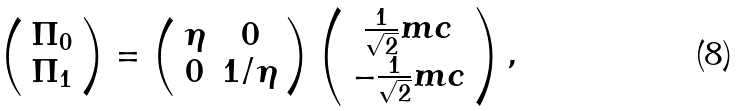Convert formula to latex. <formula><loc_0><loc_0><loc_500><loc_500>\left ( \begin{array} { c } \Pi _ { 0 } \\ \Pi _ { 1 } \end{array} \right ) = \left ( \begin{array} { c c } \eta & 0 \\ 0 & 1 / \eta \end{array} \right ) \left ( \begin{array} { c } \frac { 1 } { \sqrt { 2 } } m c \\ - \frac { 1 } { \sqrt { 2 } } m c \end{array} \right ) ,</formula> 